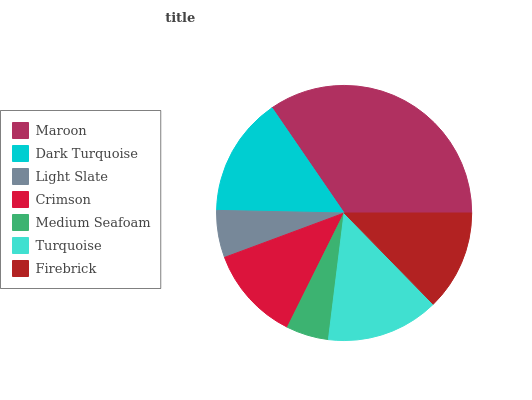Is Medium Seafoam the minimum?
Answer yes or no. Yes. Is Maroon the maximum?
Answer yes or no. Yes. Is Dark Turquoise the minimum?
Answer yes or no. No. Is Dark Turquoise the maximum?
Answer yes or no. No. Is Maroon greater than Dark Turquoise?
Answer yes or no. Yes. Is Dark Turquoise less than Maroon?
Answer yes or no. Yes. Is Dark Turquoise greater than Maroon?
Answer yes or no. No. Is Maroon less than Dark Turquoise?
Answer yes or no. No. Is Firebrick the high median?
Answer yes or no. Yes. Is Firebrick the low median?
Answer yes or no. Yes. Is Medium Seafoam the high median?
Answer yes or no. No. Is Light Slate the low median?
Answer yes or no. No. 